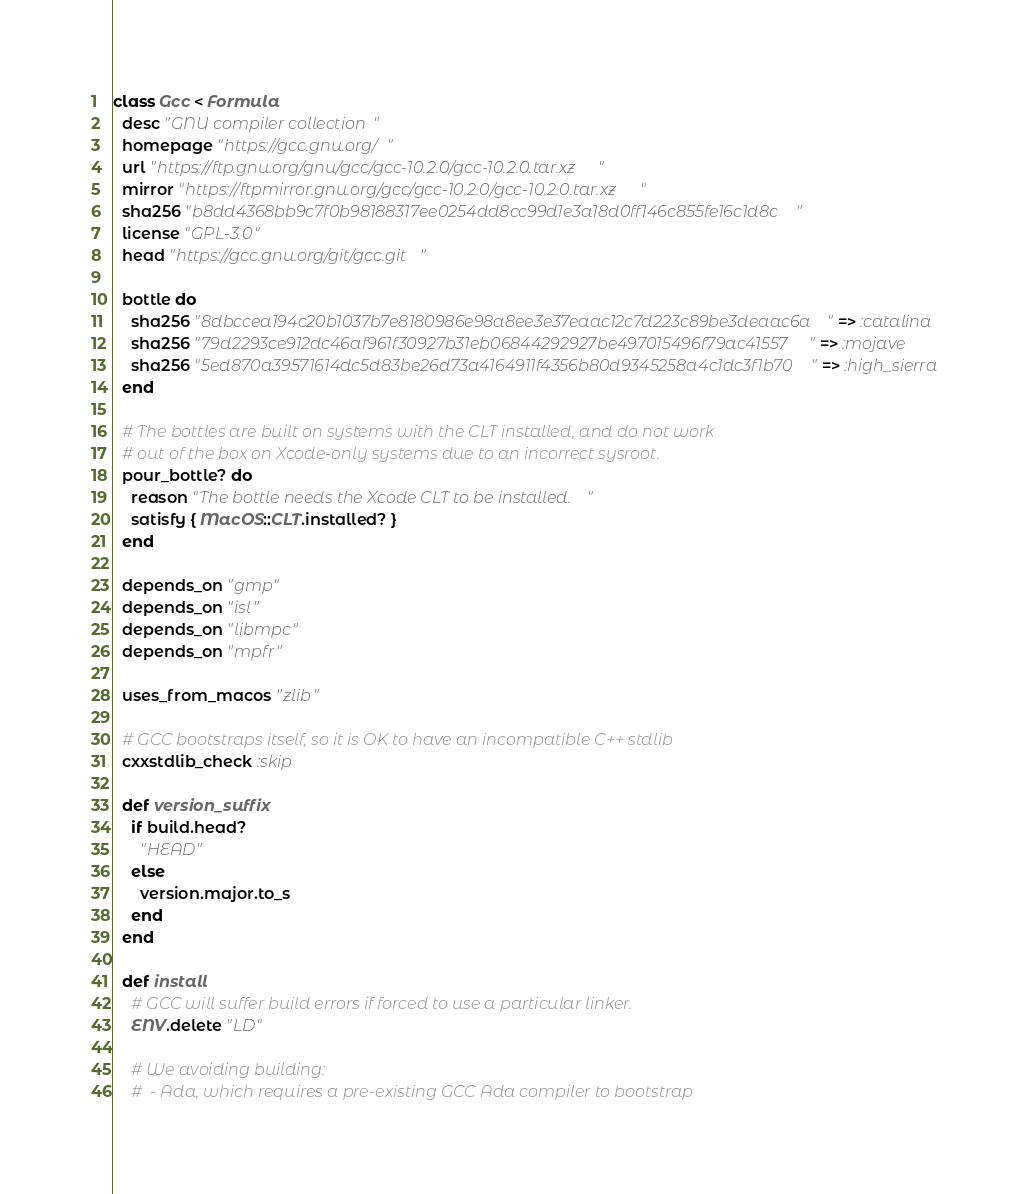Convert code to text. <code><loc_0><loc_0><loc_500><loc_500><_Ruby_>class Gcc < Formula
  desc "GNU compiler collection"
  homepage "https://gcc.gnu.org/"
  url "https://ftp.gnu.org/gnu/gcc/gcc-10.2.0/gcc-10.2.0.tar.xz"
  mirror "https://ftpmirror.gnu.org/gcc/gcc-10.2.0/gcc-10.2.0.tar.xz"
  sha256 "b8dd4368bb9c7f0b98188317ee0254dd8cc99d1e3a18d0ff146c855fe16c1d8c"
  license "GPL-3.0"
  head "https://gcc.gnu.org/git/gcc.git"

  bottle do
    sha256 "8dbccea194c20b1037b7e8180986e98a8ee3e37eaac12c7d223c89be3deaac6a" => :catalina
    sha256 "79d2293ce912dc46af961f30927b31eb06844292927be497015496f79ac41557" => :mojave
    sha256 "5ed870a39571614dc5d83be26d73a4164911f4356b80d9345258a4c1dc3f1b70" => :high_sierra
  end

  # The bottles are built on systems with the CLT installed, and do not work
  # out of the box on Xcode-only systems due to an incorrect sysroot.
  pour_bottle? do
    reason "The bottle needs the Xcode CLT to be installed."
    satisfy { MacOS::CLT.installed? }
  end

  depends_on "gmp"
  depends_on "isl"
  depends_on "libmpc"
  depends_on "mpfr"

  uses_from_macos "zlib"

  # GCC bootstraps itself, so it is OK to have an incompatible C++ stdlib
  cxxstdlib_check :skip

  def version_suffix
    if build.head?
      "HEAD"
    else
      version.major.to_s
    end
  end

  def install
    # GCC will suffer build errors if forced to use a particular linker.
    ENV.delete "LD"

    # We avoiding building:
    #  - Ada, which requires a pre-existing GCC Ada compiler to bootstrap</code> 